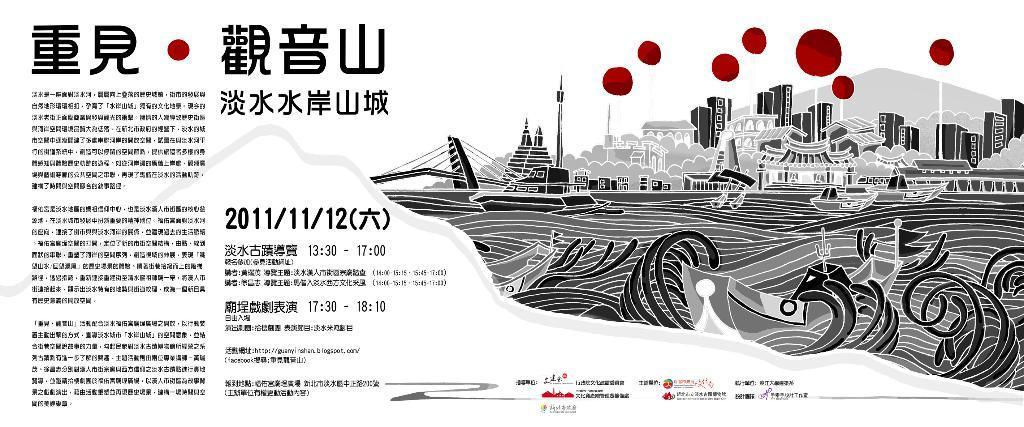In one or two sentences, can you explain what this image depicts? In this image there is a paper with some note and drawing. 